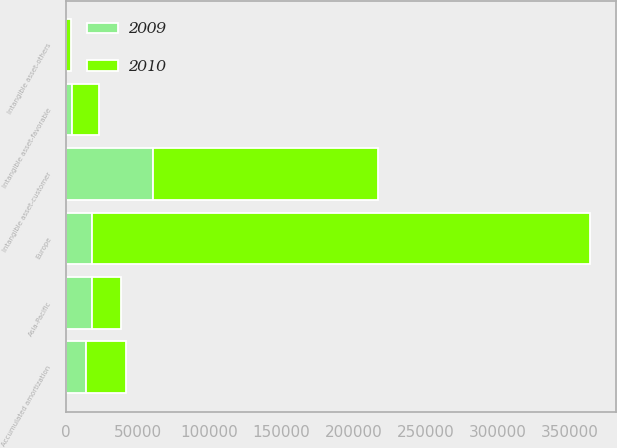Convert chart to OTSL. <chart><loc_0><loc_0><loc_500><loc_500><stacked_bar_chart><ecel><fcel>Europe<fcel>Asia-Pacific<fcel>Intangible asset-customer<fcel>Intangible asset-favorable<fcel>Intangible asset-others<fcel>Accumulated amortization<nl><fcel>2010<fcel>345486<fcel>20149<fcel>156621<fcel>18285<fcel>3483<fcel>27444<nl><fcel>2009<fcel>18481<fcel>18481<fcel>60499<fcel>4690<fcel>111<fcel>14286<nl></chart> 